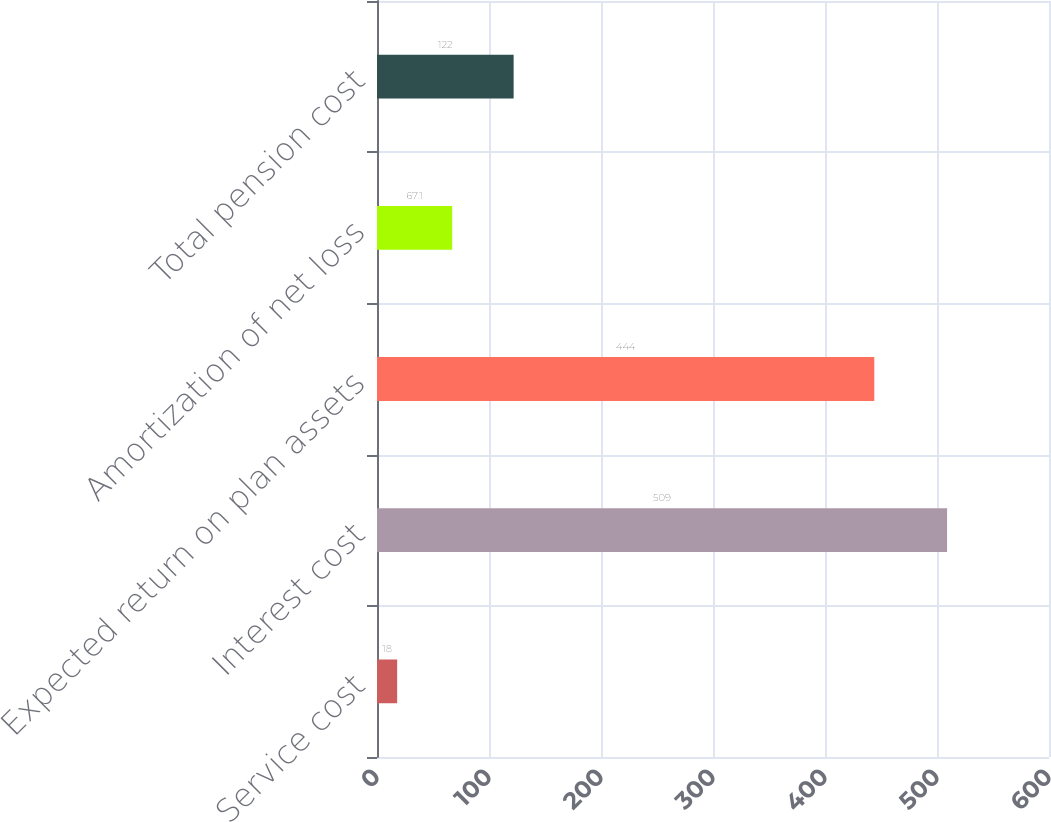Convert chart to OTSL. <chart><loc_0><loc_0><loc_500><loc_500><bar_chart><fcel>Service cost<fcel>Interest cost<fcel>Expected return on plan assets<fcel>Amortization of net loss<fcel>Total pension cost<nl><fcel>18<fcel>509<fcel>444<fcel>67.1<fcel>122<nl></chart> 